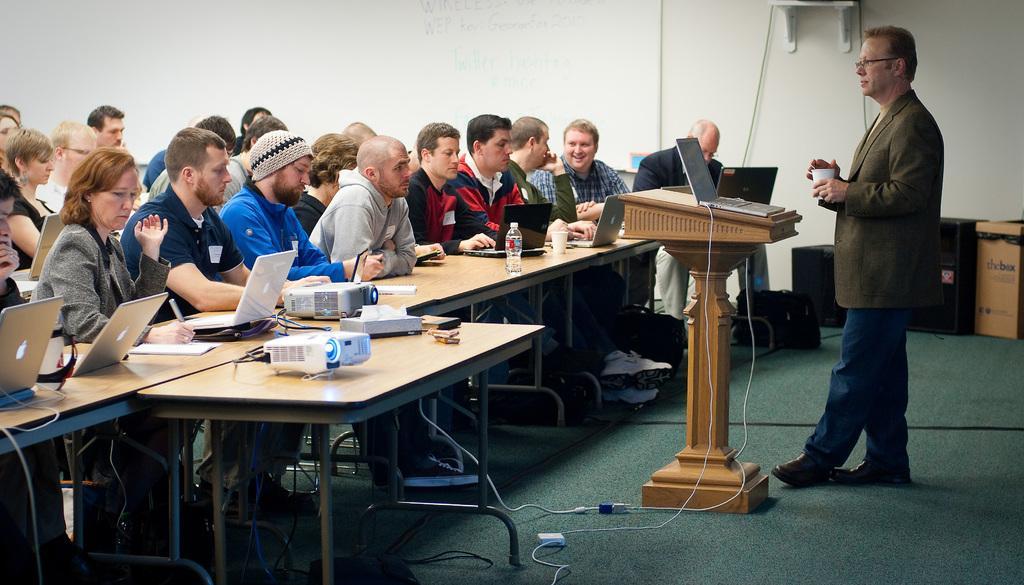Can you describe this image briefly? A picture of a inside room. A group of people are sitting on a chair. In-front of them there is a table, on a table there is a projector, laptop, paper, cup and bottle. This man is standing and holding a cup. In-front of this man there is a podium. On a podium there is a laptop. This are cardboard box. Sound box. Floor with carpet. 